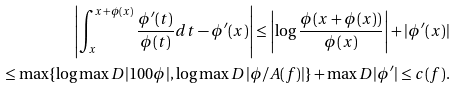Convert formula to latex. <formula><loc_0><loc_0><loc_500><loc_500>\left | \int _ { x } ^ { x + \phi ( x ) } \frac { \phi ^ { \prime } ( t ) } { \phi ( t ) } d t - \phi ^ { \prime } ( x ) \right | \leq \left | \log \frac { \phi ( x + \phi ( x ) ) } { \phi ( x ) } \right | + | \phi ^ { \prime } ( x ) | \\ \leq \max \{ \log \max _ { \ } D | 1 0 0 \phi | , \log \max _ { \ } D | \phi / A ( f ) | \} + \max _ { \ } D | \phi ^ { \prime } | \leq c ( f ) .</formula> 